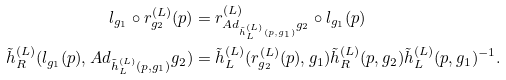<formula> <loc_0><loc_0><loc_500><loc_500>l _ { g _ { 1 } } \circ r _ { g _ { 2 } } ^ { ( L ) } ( p ) & = r ^ { ( L ) } _ { A d _ { \tilde { h } _ { L } ^ { ( L ) } ( p , g _ { 1 } ) } g _ { 2 } } \circ l _ { g _ { 1 } } ( p ) \\ \tilde { h } _ { R } ^ { ( L ) } ( l _ { g _ { 1 } } ( p ) , A d _ { \tilde { h } _ { L } ^ { ( L ) } ( p , g _ { 1 } ) } g _ { 2 } ) & = \tilde { h } _ { L } ^ { ( L ) } ( r ^ { ( L ) } _ { g _ { 2 } } ( p ) , g _ { 1 } ) \tilde { h } _ { R } ^ { ( L ) } ( p , g _ { 2 } ) \tilde { h } _ { L } ^ { ( L ) } ( p , g _ { 1 } ) ^ { - 1 } .</formula> 